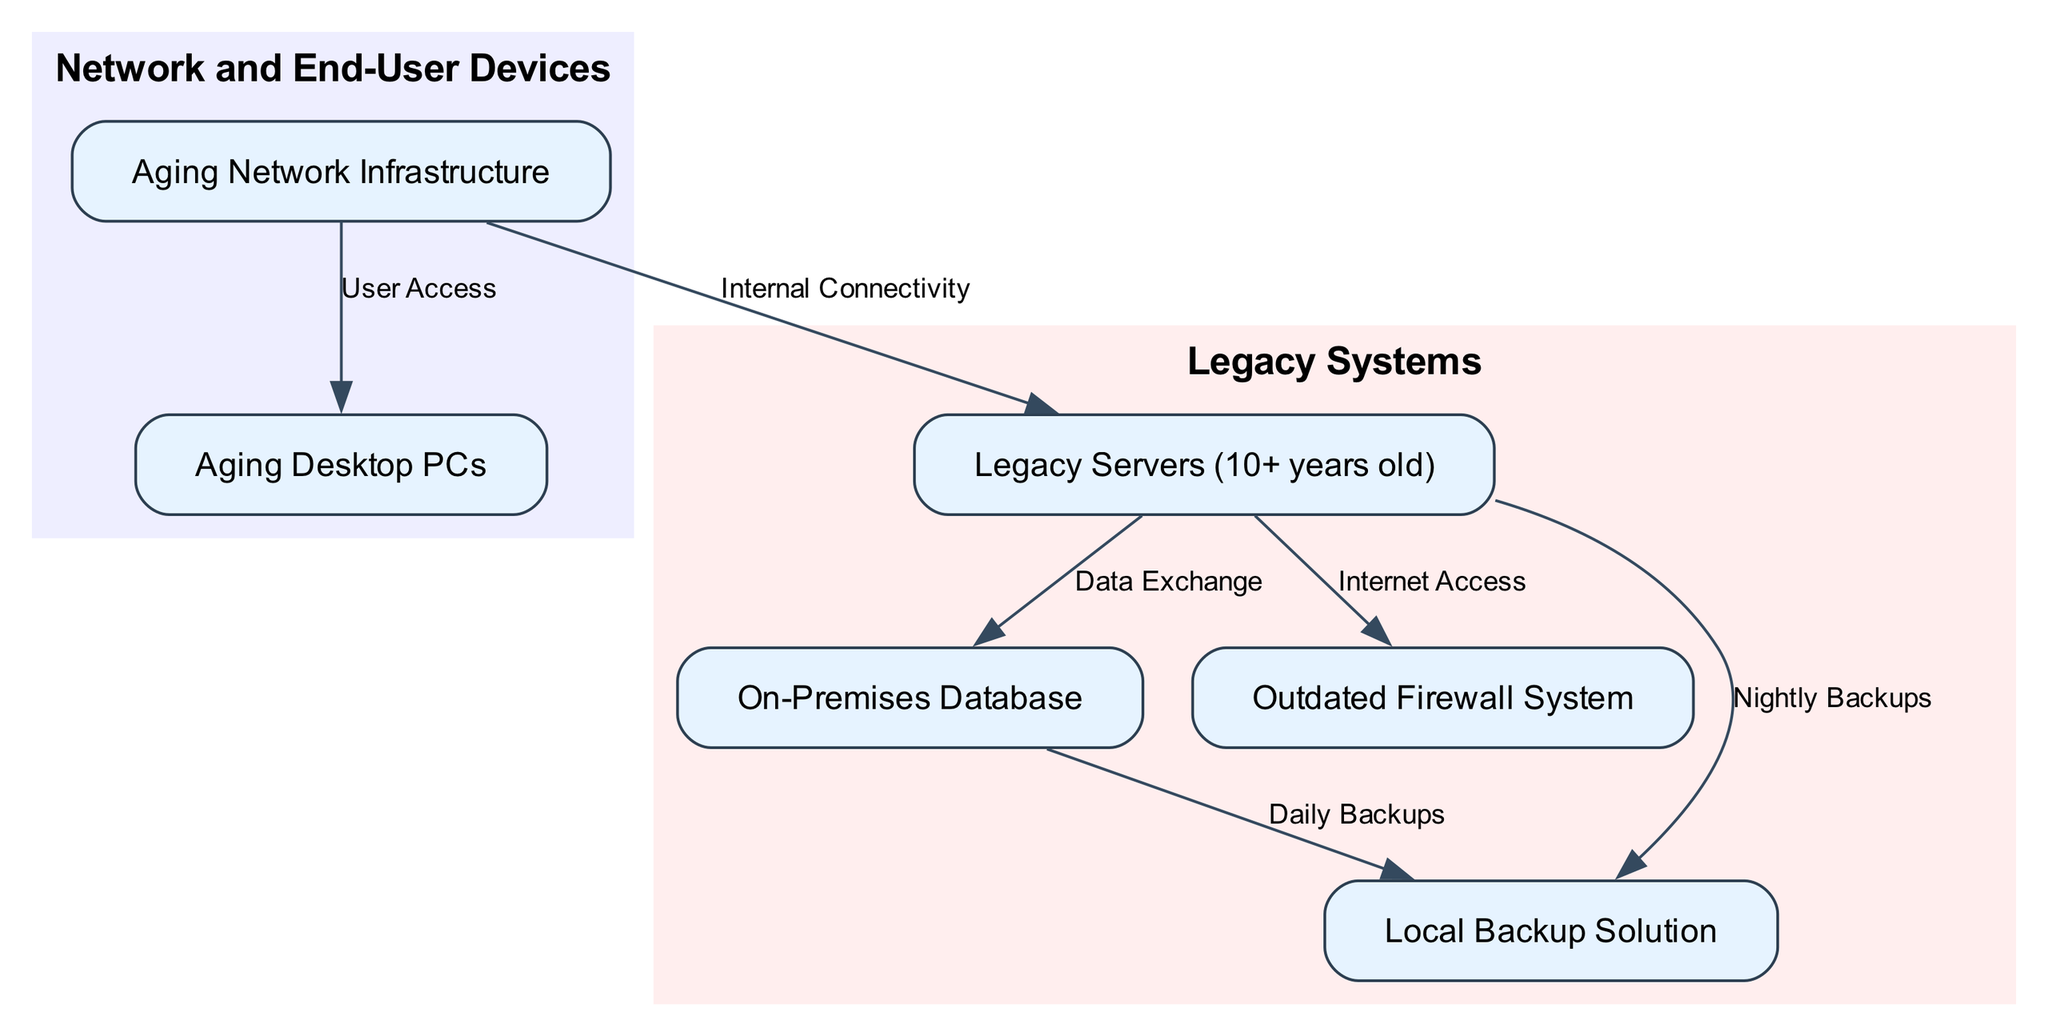What is the total number of nodes in the diagram? The diagram contains six nodes: Legacy Servers, On-Premises Database, Outdated Firewall System, Local Backup Solution, Aging Network Infrastructure, and Aging Desktop PCs.
Answer: 6 What does the On-Premises Database exchange data with? The On-Premises Database exchanges data with the Legacy Servers, as indicated by the directed edge labeled "Data Exchange" from Legacy Servers to On-Premises Database.
Answer: Legacy Servers How many edges are present in the diagram? The diagram has five edges connecting various nodes. These include Data Exchange, Internet Access, Nightly Backups, Daily Backups, and Internal Connectivity.
Answer: 5 Which node is not part of the legacy systems subgraph? The desktop PCs node is part of the separate subgraph labeled "Network and End-User Devices" and not included in the "Legacy Systems" subgraph.
Answer: Aging Desktop PCs Which node is connected to the Old Network for User Access? The Aging Desktop PCs node is connected to the Old Network specifically for user access. This relationship is shown by the labeled edge issued from Old Network to Desktop PCs.
Answer: Aging Desktop PCs How does the legacy servers connect to the backup solution? The connection from the Legacy Servers to the Local Backup Solution is established through the edge that states "Nightly Backups." This shows that the Legacy Servers perform this function in relation to the Local Backup.
Answer: Nightly Backups What is the label of the edge connecting the Old Network to Legacy Servers? The label of the edge connecting the Old Network to Legacy Servers is "Internal Connectivity," highlighting the relationship of connectivity within the network infrastructure.
Answer: Internal Connectivity Which component is indicated as the aging part of the IT infrastructure? The diagram includes several aging components, specifically citing Aging Network Infrastructure and Aging Desktop PCs as key elements highlighted for modernization.
Answer: Aging Network Infrastructure and Aging Desktop PCs What type of firewall system is indicated in the diagram? The diagram indicates an "Outdated Firewall System," highlighting the need for an upgrade or modernization in this area of the infrastructure.
Answer: Outdated Firewall System 